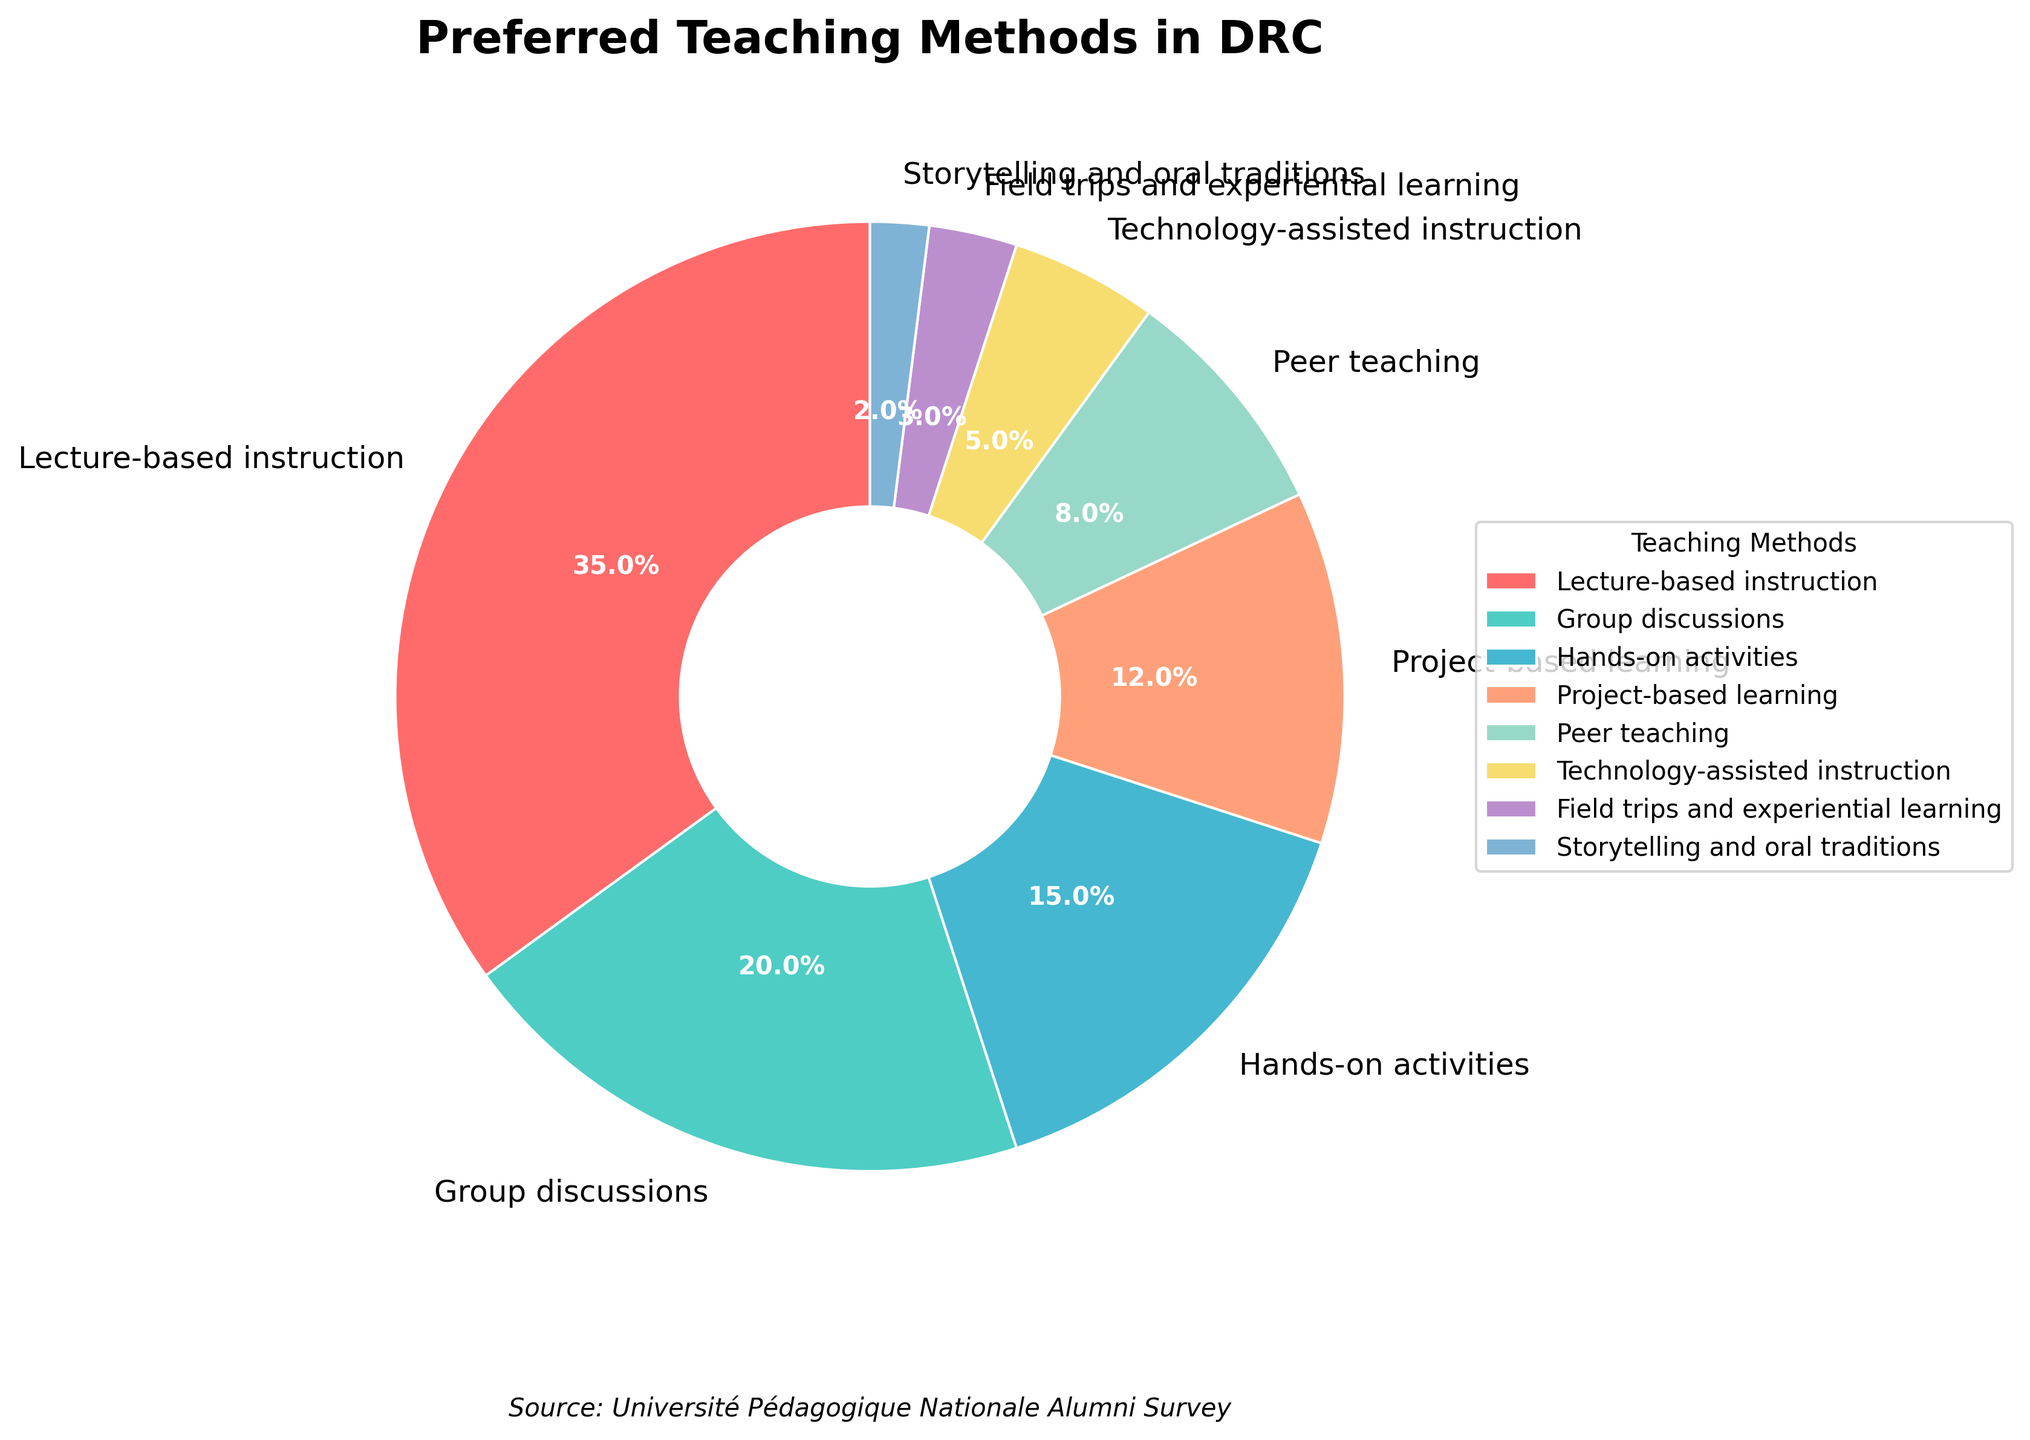Which teaching method is preferred by the highest percentage of educators in the DRC? The figure shows that the largest wedge represents "Lecture-based instruction," which occupies 35% of the pie chart.
Answer: Lecture-based instruction How much more popular are group discussions compared to peer teaching? According to the figure, group discussions have a percentage of 20%, while peer teaching has 8%. The difference is calculated as 20% - 8% = 12%.
Answer: 12% Which teaching method is the least preferred among educators in the DRC? The smallest wedge in the pie chart represents "Storytelling and oral traditions," accounting for 2% of the pie chart.
Answer: Storytelling and oral traditions What is the combined percentage of hands-on activities and project-based learning? The percentages for hands-on activities and project-based learning are 15% and 12%, respectively. Their combined percentage is 15% + 12% = 27%.
Answer: 27% How does the preference for technology-assisted instruction compare to field trips and experiential learning? The figure shows that technology-assisted instruction is preferred by 5% of educators, while field trips and experiential learning are preferred by 3%. Thus, technology-assisted instruction is more popular.
Answer: Technology-assisted instruction is more popular How many teaching methods have a preference percentage of 10% or higher? According to the pie chart, the methods with 10% or higher preferences are "Lecture-based instruction" (35%), "Group discussions" (20%), "Hands-on activities" (15%), and "Project-based learning" (12%). There are 4 methods in total.
Answer: 4 What is the difference in preference between lecture-based instruction and the second most preferred method? Lecture-based instruction has a preference of 35%, and the second most preferred method, group discussions, has 20%. The difference is 35% - 20% = 15%.
Answer: 15% What proportion of the pie chart is made up by peer teaching, technology-assisted instruction, and field trips and experiential learning combined? Summing the percentages, peer teaching is 8%, technology-assisted instruction is 5%, and field trips and experiential learning are 3%. Their combined percentage is 8% + 5% + 3% = 16%.
Answer: 16% Which method is shown with a light purple color on the pie chart? The legend indicates that the light purple color corresponds to peer teaching, which is shown with an 8% preference.
Answer: Peer teaching 